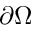<formula> <loc_0><loc_0><loc_500><loc_500>\partial \Omega</formula> 